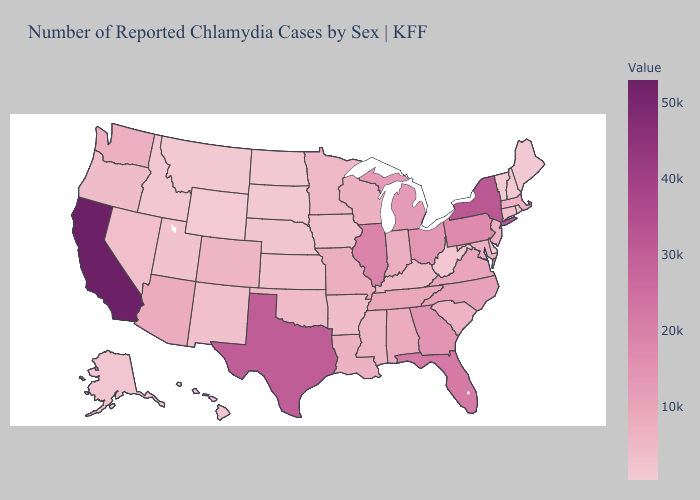Does Louisiana have a higher value than Pennsylvania?
Concise answer only. No. Does North Carolina have a lower value than New York?
Keep it brief. Yes. Among the states that border Indiana , does Kentucky have the lowest value?
Give a very brief answer. Yes. Does Washington have a higher value than Florida?
Keep it brief. No. Does Massachusetts have the lowest value in the Northeast?
Short answer required. No. Among the states that border Rhode Island , which have the lowest value?
Write a very short answer. Connecticut. Does the map have missing data?
Write a very short answer. No. 